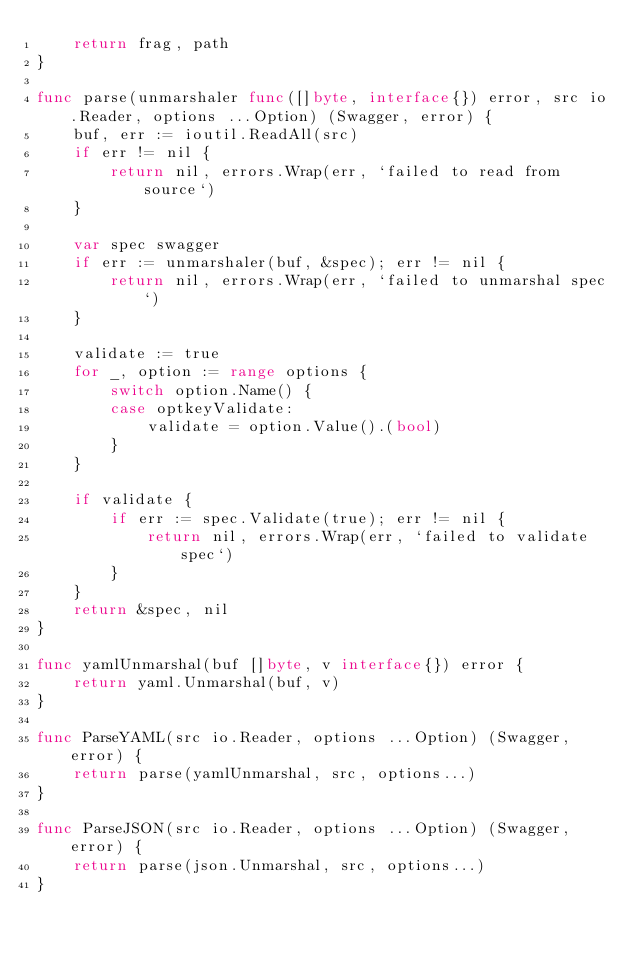<code> <loc_0><loc_0><loc_500><loc_500><_Go_>	return frag, path
}

func parse(unmarshaler func([]byte, interface{}) error, src io.Reader, options ...Option) (Swagger, error) {
	buf, err := ioutil.ReadAll(src)
	if err != nil {
		return nil, errors.Wrap(err, `failed to read from source`)
	}

	var spec swagger
	if err := unmarshaler(buf, &spec); err != nil {
		return nil, errors.Wrap(err, `failed to unmarshal spec`)
	}

	validate := true
	for _, option := range options {
		switch option.Name() {
		case optkeyValidate:
			validate = option.Value().(bool)
		}
	}

	if validate {
		if err := spec.Validate(true); err != nil {
			return nil, errors.Wrap(err, `failed to validate spec`)
		}
	}
	return &spec, nil
}

func yamlUnmarshal(buf []byte, v interface{}) error {
	return yaml.Unmarshal(buf, v)
}

func ParseYAML(src io.Reader, options ...Option) (Swagger, error) {
	return parse(yamlUnmarshal, src, options...)
}

func ParseJSON(src io.Reader, options ...Option) (Swagger, error) {
	return parse(json.Unmarshal, src, options...)
}
</code> 